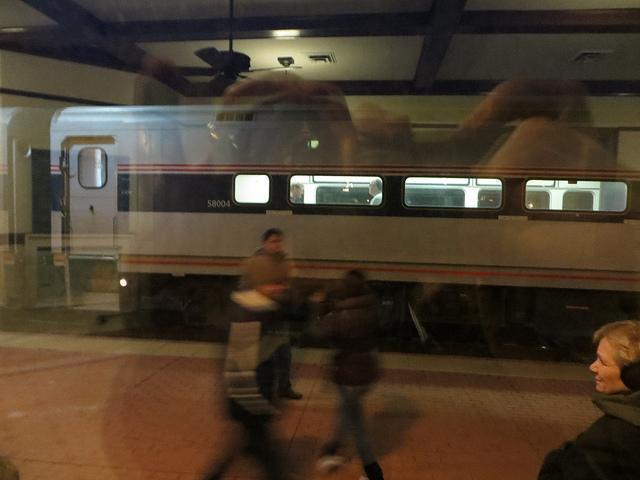How many people can be seen?
Give a very brief answer. 3. 